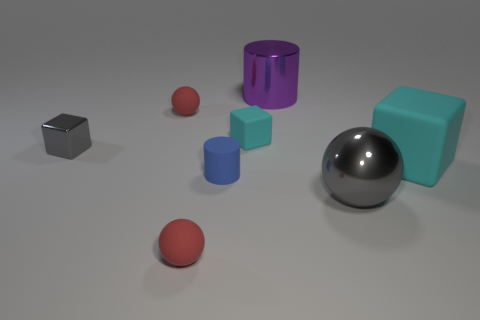What is the arrangement of the objects in the image? The objects are arranged in a scattered manner across a flat surface. From left to right, we see a small cube, a small sphere, a larger sphere, a cylinder, and a larger cube-like block. There is no clear pattern to their arrangement, suggesting a random placement rather than a deliberate composition. 